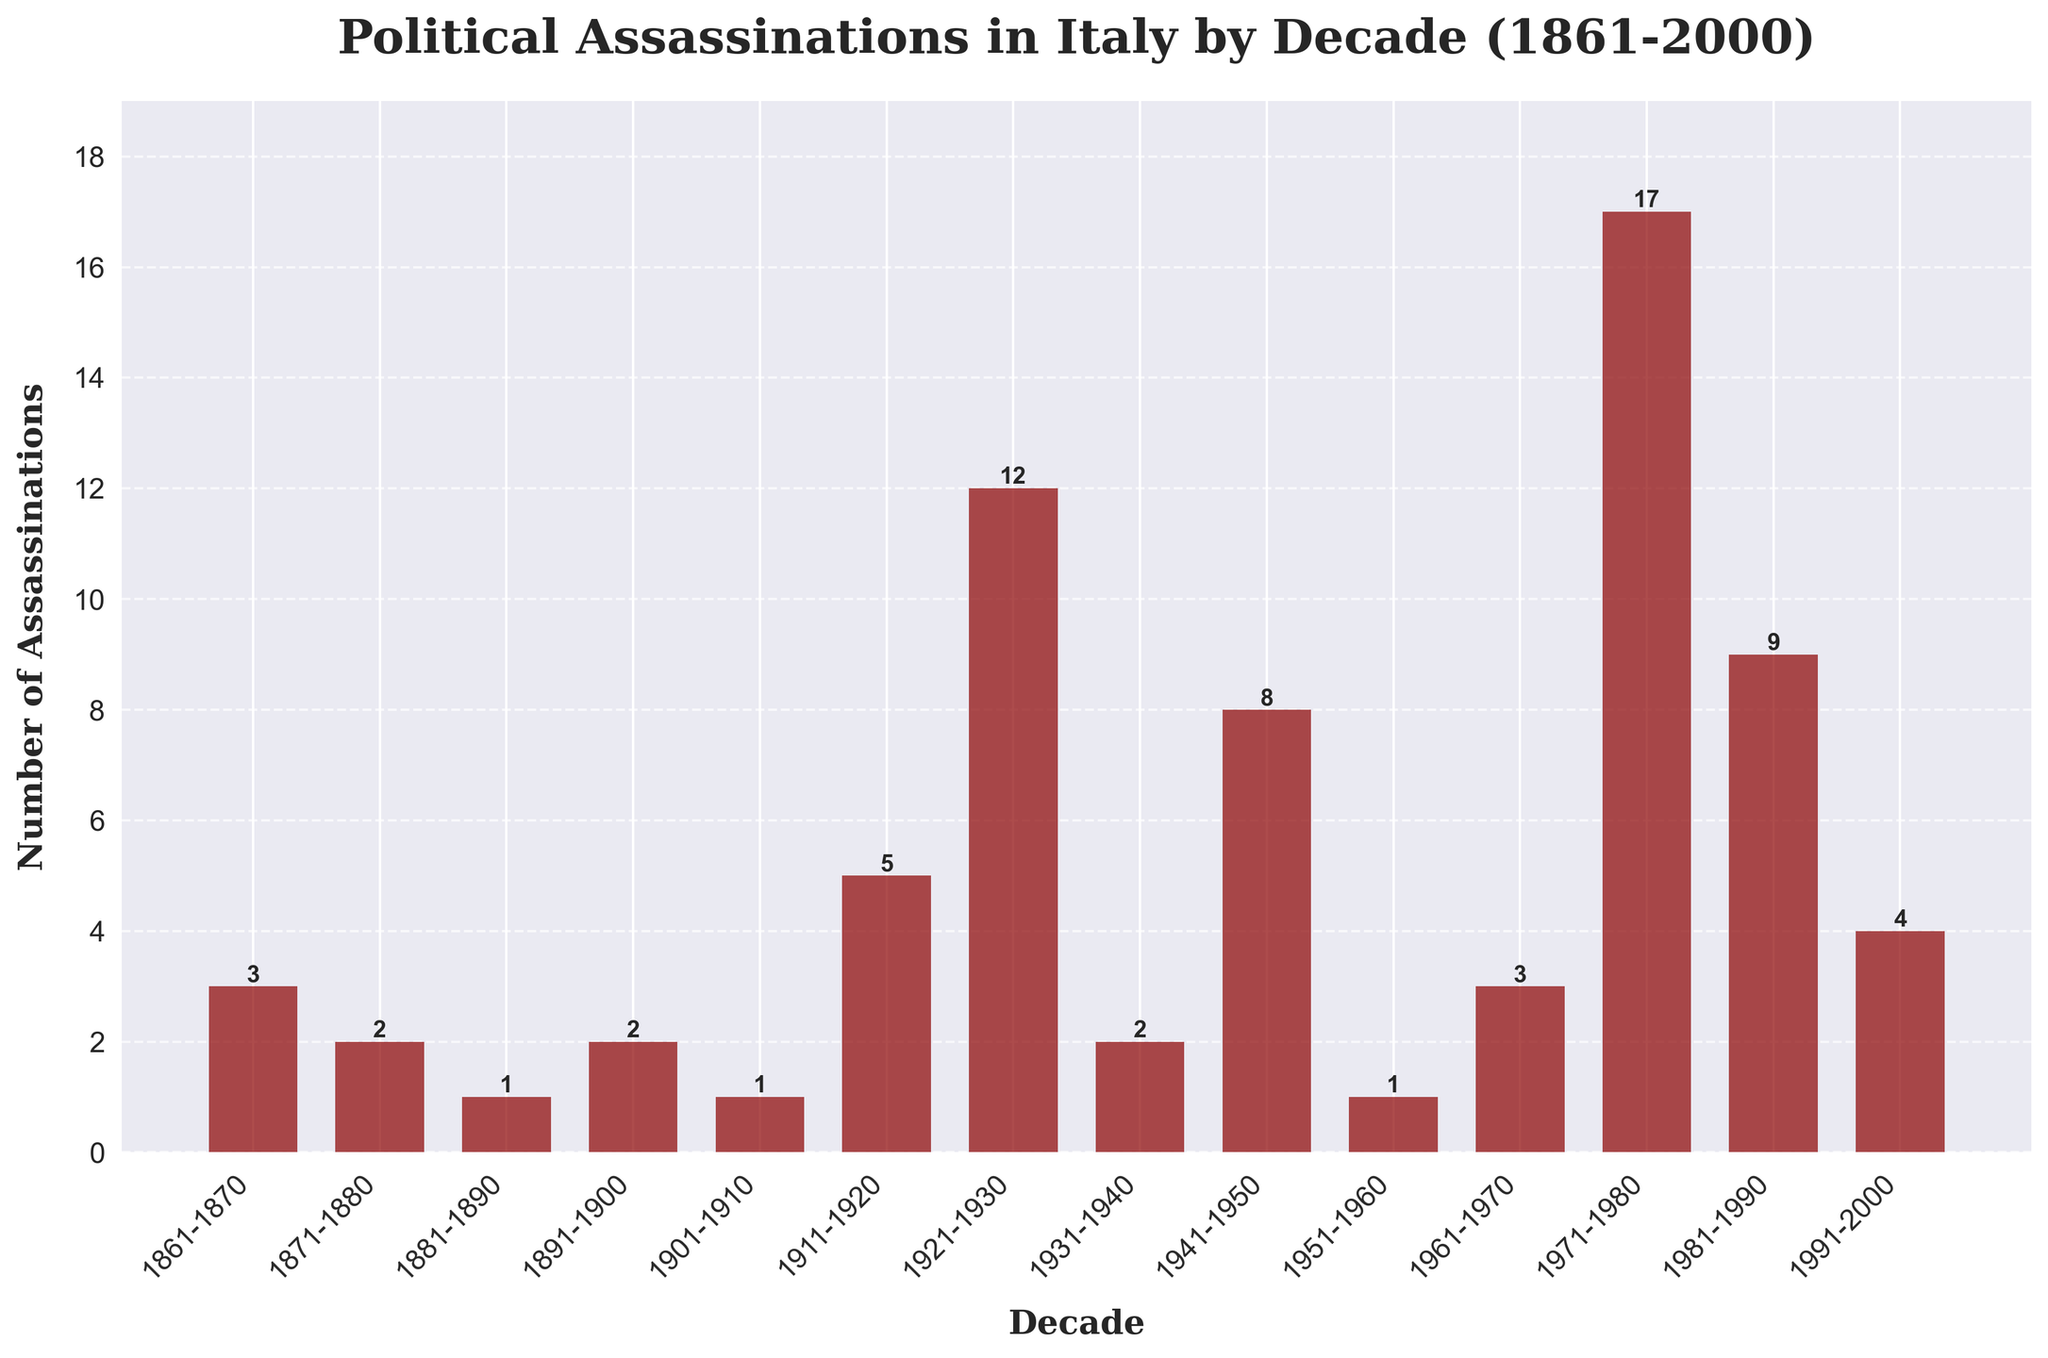What is the total number of political assassinations in Italy from 1971 to 2000? To find the total number of political assassinations from 1971 to 2000, sum up the assassinations from the decades 1971-1980, 1981-1990, and 1991-2000: 17 + 9 + 4 = 30
Answer: 30 Which decade had the highest number of political assassinations? Compare the heights of the bars to identify the tallest one. The tallest bar represents the decade 1971-1980 with 17 assassinations
Answer: 1971-1980 How many more political assassinations were there in 1921-1930 compared to 1911-1920? Find the difference in the number of assassinations between the decades: 12 (1921-1930) - 5 (1911-1920) = 7
Answer: 7 What is the average number of political assassinations per decade from 1861 to 1900? Add the number of assassinations from the decades 1861-1870, 1871-1880, 1881-1890, and 1891-1900, then divide by 4: (3 + 2 + 1 + 2) / 4 = 2
Answer: 2 During which decade did the number of political assassinations first exceed 10? Examine the bars and identify the first bar that surpasses the height representing 10 assassinations. This occurs in the decade 1921-1930 with 12 assassinations
Answer: 1921-1930 How many decades had fewer than 5 political assassinations? Count the bars representing fewer than 5 assassinations: decades 1861-1870, 1871-1880, 1881-1890, 1891-1900, 1901-1910, 1931-1940, 1951-1960, and 1991-2000 (8 decades)
Answer: 8 What is the median number of political assassinations per decade from 1861 to 2000? Arrange the numbers of assassinations per decade in ascending order: 1, 1, 1, 2, 2, 2, 3, 3, 4, 5, 8, 9, 12, 17. The median value (middle value in sorted list) is the average of the 7th and 8th values: (3 + 3) / 2 = 3
Answer: 3 